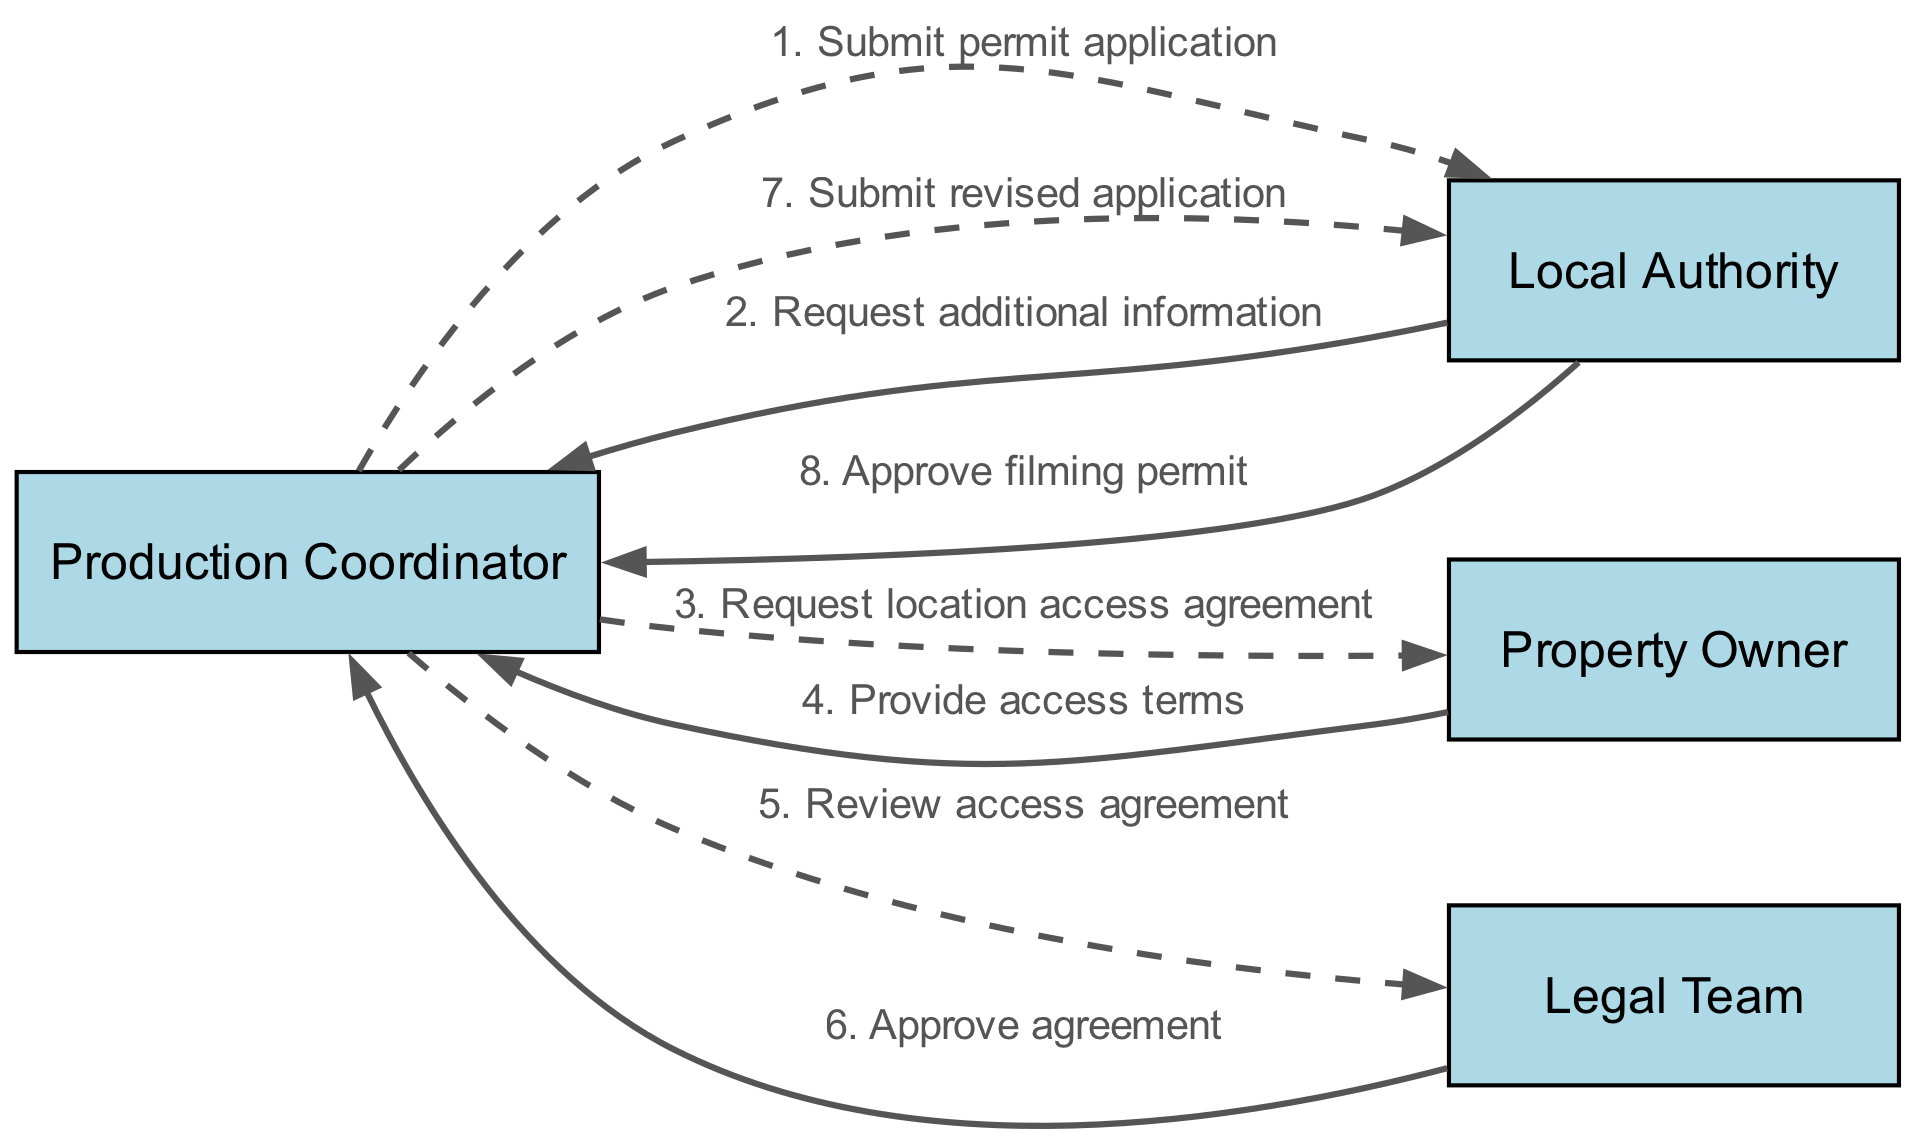What actors are involved in the workflow? The diagram lists four actors, which include the Production Coordinator, Local Authority, Property Owner, and Legal Team.
Answer: Production Coordinator, Local Authority, Property Owner, Legal Team How many interactions are shown in the diagram? There are a total of eight interactions depicted in the sequence diagram, connecting the actors via messages based on the workflow.
Answer: Eight What is the first interaction in the workflow? The first interaction is between the Production Coordinator and the Local Authority, where the Production Coordinator submits the permit application.
Answer: Submit permit application Who is responsible for requesting additional information? The Local Authority is responsible for requesting additional information from the Production Coordinator after the permit application is submitted.
Answer: Local Authority What document does the Production Coordinator seek from the Property Owner? The Production Coordinator requests a location access agreement from the Property Owner to proceed with the filming permit process.
Answer: Location access agreement What is the final step in the workflow? The final step involves the Local Authority approving the filming permit after the Production Coordinator submits the revised application.
Answer: Approve filming permit Which team reviews the access agreement? The Legal Team is the one that reviews the access agreement provided by the Property Owner.
Answer: Legal Team What type of message does the production coordinator send to the local authority after the access agreement is approved? The Production Coordinator submits a revised application to the Local Authority after receiving approval from the Legal Team regarding the access agreement.
Answer: Submit revised application How many approvals are required for the filming permit? Two approvals are needed: one from the Legal Team for the access agreement and another from the Local Authority for the filming permit itself.
Answer: Two 